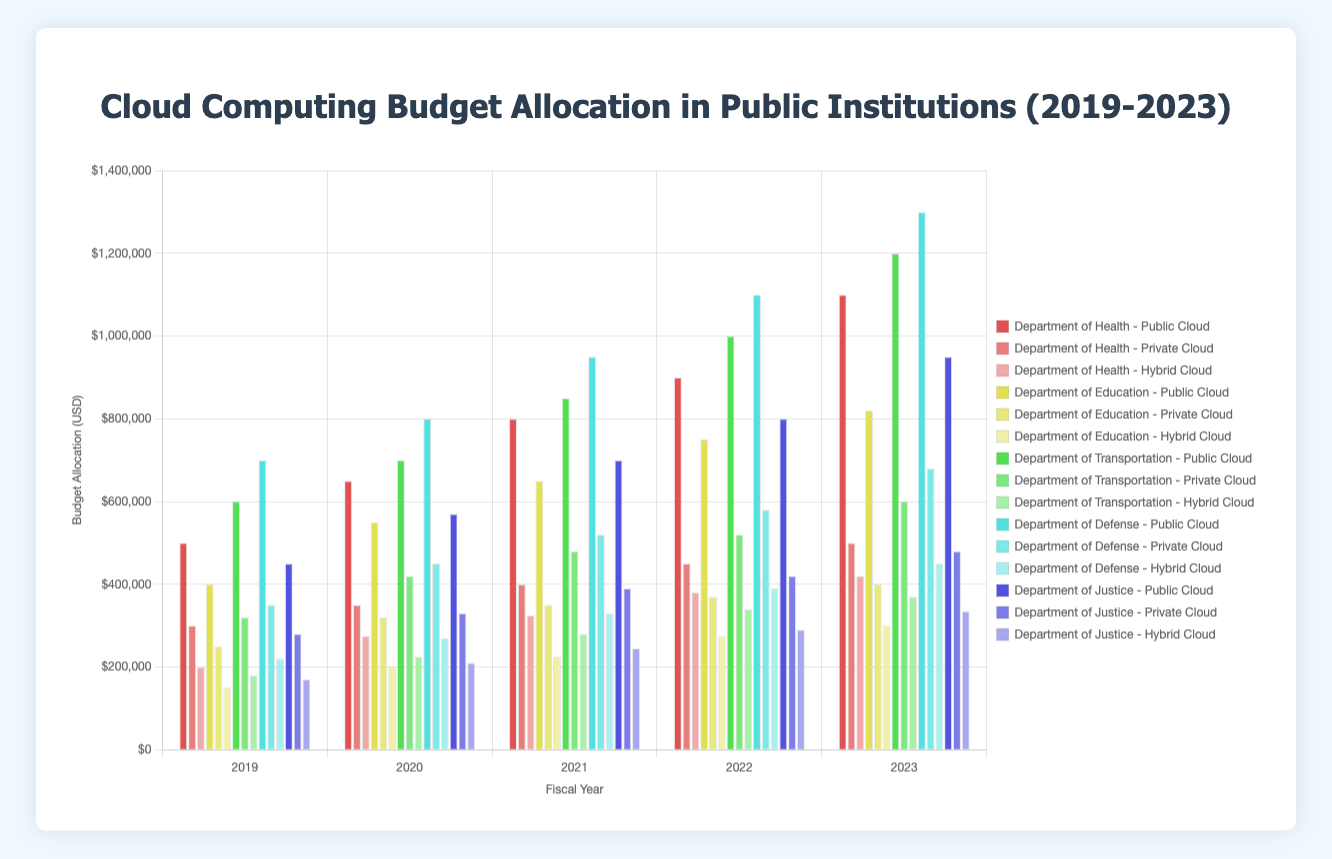How has the budget allocation for the Public Cloud model in the Department of Health changed from 2019 to 2023? Observe the Public Cloud bars for the Department of Health across the years 2019 to 2023. In 2019 it was $500,000, in 2020 it was $650,000, in 2021 it was $800,000, in 2022 it was $900,000, and in 2023 it was $1,100,000. The budget allocation has increased every year.
Answer: Increased every year Which deployment model received the highest budget allocation for the Department of Justice in 2023? Compare the bars representing the budget allocation for Public Cloud, Private Cloud, and Hybrid Cloud for the Department of Justice in 2023. The highest bar is the Public Cloud, with a budget of $950,000.
Answer: Public Cloud What is the total budget allocation for cloud computing in the Department of Education in 2022? Sum the budget allocations for Public Cloud, Private Cloud, and Hybrid Cloud for the Department of Education in 2022. Public Cloud: $750,000, Private Cloud: $370,000, and Hybrid Cloud: $275,000. Total = $750,000 + $370,000 + $275,000 = $1,395,000
Answer: $1,395,000 How does the budget allocation for the Hybrid Cloud in the Department of Defense in 2022 compare to 2023? Compare the height of the bars representing Hybrid Cloud for the Department of Defense in 2022 and 2023. In 2022, it was $390,000, and in 2023, it was $450,000. The budget increased by $60,000.
Answer: Increased by $60,000 Between the Departments of Health and Transportation, which one had a higher total budget allocation for Public Cloud over the period 2019-2023? Add the Public Cloud budget allocations for the years 2019 to 2023 for both departments. Department of Health: $500,000 + $650,000 + $800,000 + $900,000 + $1,100,000 = $3,950,000. Department of Transportation: $600,000 + $700,000 + $850,000 + $1,000,000 + $1,200,000 = $4,350,000. Compare the totals.
Answer: Department of Transportation What is the average annual budget allocation for Private Cloud in the Department of Defense from 2019 to 2023? Sum the Private Cloud budget allocations for the years 2019 to 2023 for the Department of Defense and divide by 5. The allocations are $350,000, $450,000, $520,000, $580,000, and $680,000. Total = $350,000 + $450,000 + $520,000 + $580,000 + $680,000 = $2,580,000. Average = $2,580,000 / 5 = $516,000
Answer: $516,000 In which year did the Department of Education allocate the least budget to Hybrid Cloud? Compare the heights of the Hybrid Cloud bars for the Department of Education across all years. The lowest bar is for the year 2019, with a budget of $150,000.
Answer: 2019 By how much did the total budget allocation for Private Cloud in the Department of Health increase from 2019 to 2023? Subtract the 2019 budget allocation from the 2023 budget allocation for Private Cloud in the Department of Health. The allocations are $300,000 in 2019 and $500,000 in 2023. Difference = $500,000 - $300,000 = $200,000
Answer: $200,000 